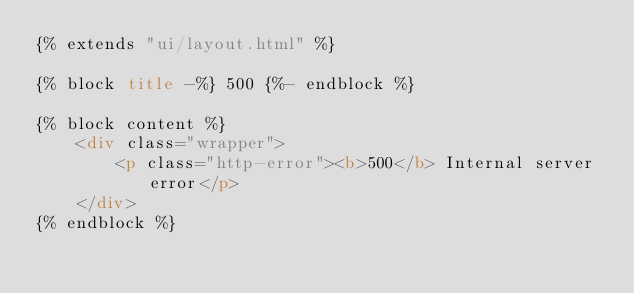Convert code to text. <code><loc_0><loc_0><loc_500><loc_500><_HTML_>{% extends "ui/layout.html" %}

{% block title -%} 500 {%- endblock %}

{% block content %}
    <div class="wrapper">
        <p class="http-error"><b>500</b> Internal server error</p>
    </div>
{% endblock %}
</code> 